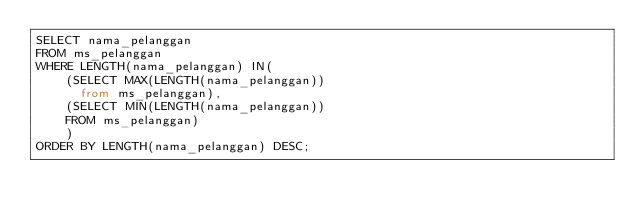Convert code to text. <code><loc_0><loc_0><loc_500><loc_500><_SQL_>SELECT nama_pelanggan
FROM ms_pelanggan
WHERE LENGTH(nama_pelanggan) IN( 
	(SELECT MAX(LENGTH(nama_pelanggan))
	  from ms_pelanggan), 
	(SELECT MIN(LENGTH(nama_pelanggan))
	FROM ms_pelanggan)
	)
ORDER BY LENGTH(nama_pelanggan) DESC;</code> 